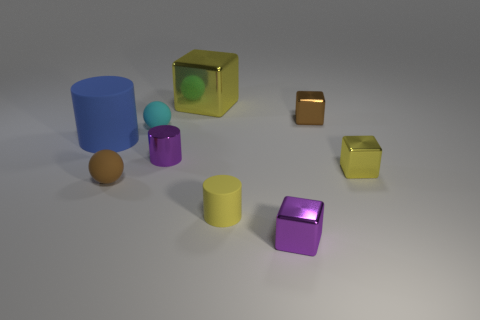Is the number of small purple things that are in front of the purple cylinder the same as the number of yellow rubber cylinders?
Offer a very short reply. Yes. Is the color of the big block the same as the rubber cylinder that is to the right of the blue thing?
Give a very brief answer. Yes. What color is the cylinder that is to the right of the brown rubber ball and left of the large yellow thing?
Your answer should be compact. Purple. What number of small yellow matte cylinders are on the left side of the purple object that is to the right of the big yellow shiny object?
Make the answer very short. 1. Are there any other matte objects of the same shape as the tiny yellow rubber thing?
Provide a succinct answer. Yes. There is a big blue object that is on the left side of the brown matte sphere; does it have the same shape as the brown thing behind the big matte object?
Provide a short and direct response. No. What number of objects are red blocks or yellow cubes?
Your response must be concise. 2. The shiny object that is the same shape as the blue rubber thing is what size?
Make the answer very short. Small. Are there more tiny yellow rubber cylinders that are behind the cyan matte ball than tiny brown shiny cubes?
Provide a short and direct response. No. Is the tiny purple cube made of the same material as the small cyan object?
Your answer should be compact. No. 